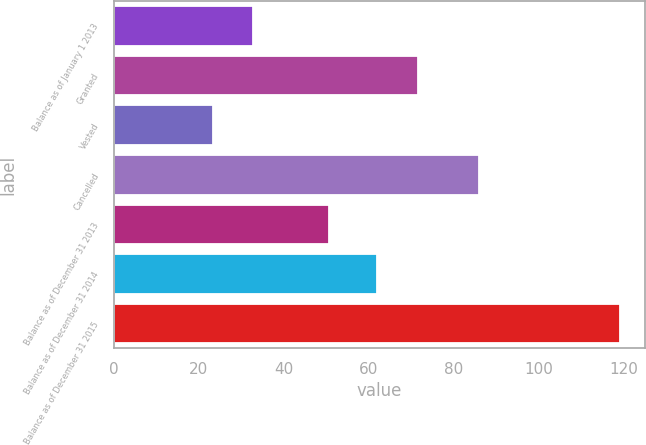Convert chart to OTSL. <chart><loc_0><loc_0><loc_500><loc_500><bar_chart><fcel>Balance as of January 1 2013<fcel>Granted<fcel>Vested<fcel>Cancelled<fcel>Balance as of December 31 2013<fcel>Balance as of December 31 2014<fcel>Balance as of December 31 2015<nl><fcel>32.88<fcel>71.56<fcel>23.29<fcel>86.1<fcel>50.64<fcel>61.97<fcel>119.2<nl></chart> 